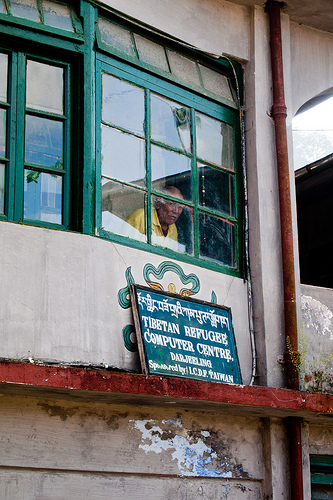<image>
Is the window behind the man? No. The window is not behind the man. From this viewpoint, the window appears to be positioned elsewhere in the scene. Where is the man in relation to the sign? Is it above the sign? Yes. The man is positioned above the sign in the vertical space, higher up in the scene. 